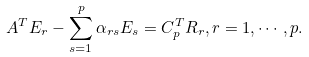<formula> <loc_0><loc_0><loc_500><loc_500>A ^ { T } E _ { r } - \sum _ { s = 1 } ^ { p } \alpha _ { r s } E _ { s } = C _ { p } ^ { T } R _ { r } , r = 1 , \cdots , p .</formula> 